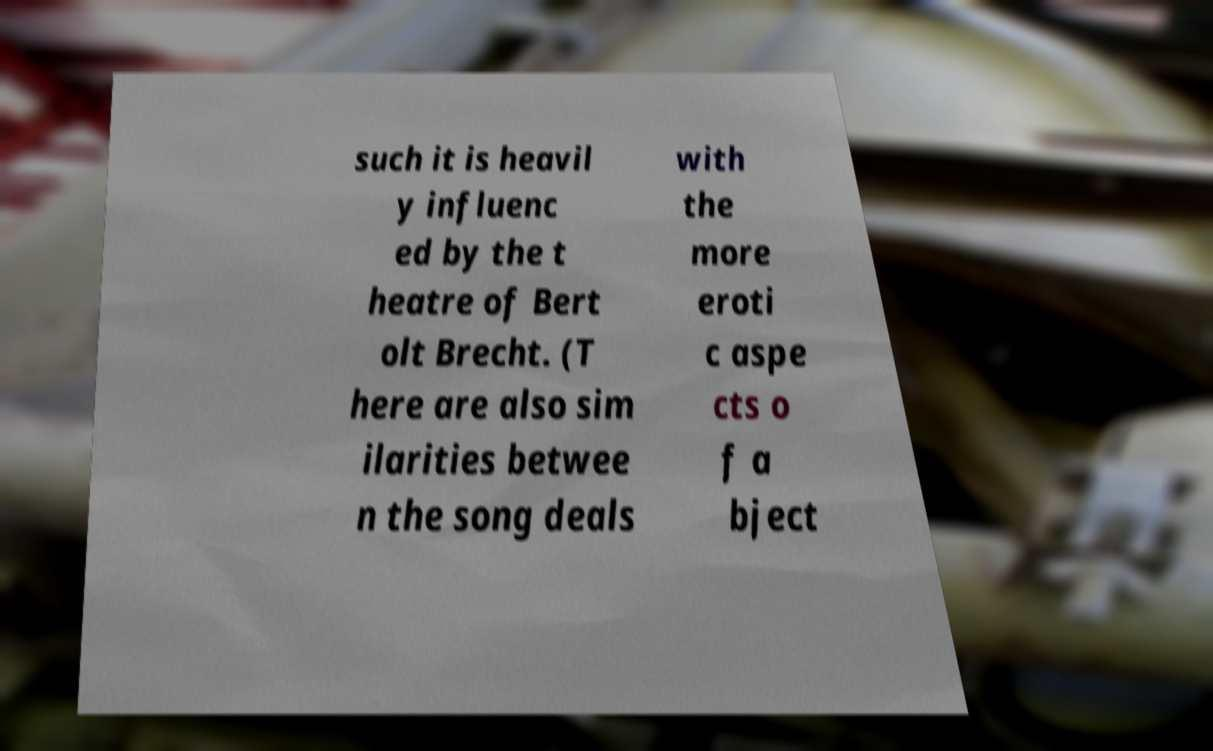There's text embedded in this image that I need extracted. Can you transcribe it verbatim? such it is heavil y influenc ed by the t heatre of Bert olt Brecht. (T here are also sim ilarities betwee n the song deals with the more eroti c aspe cts o f a bject 